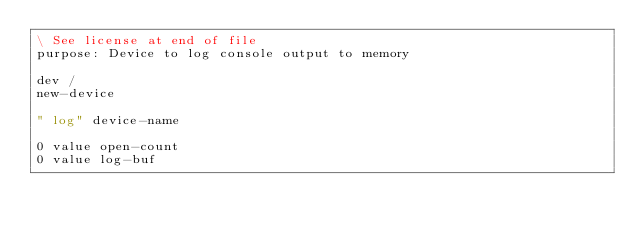Convert code to text. <code><loc_0><loc_0><loc_500><loc_500><_Forth_>\ See license at end of file
purpose: Device to log console output to memory

dev /
new-device

" log" device-name

0 value open-count
0 value log-buf</code> 